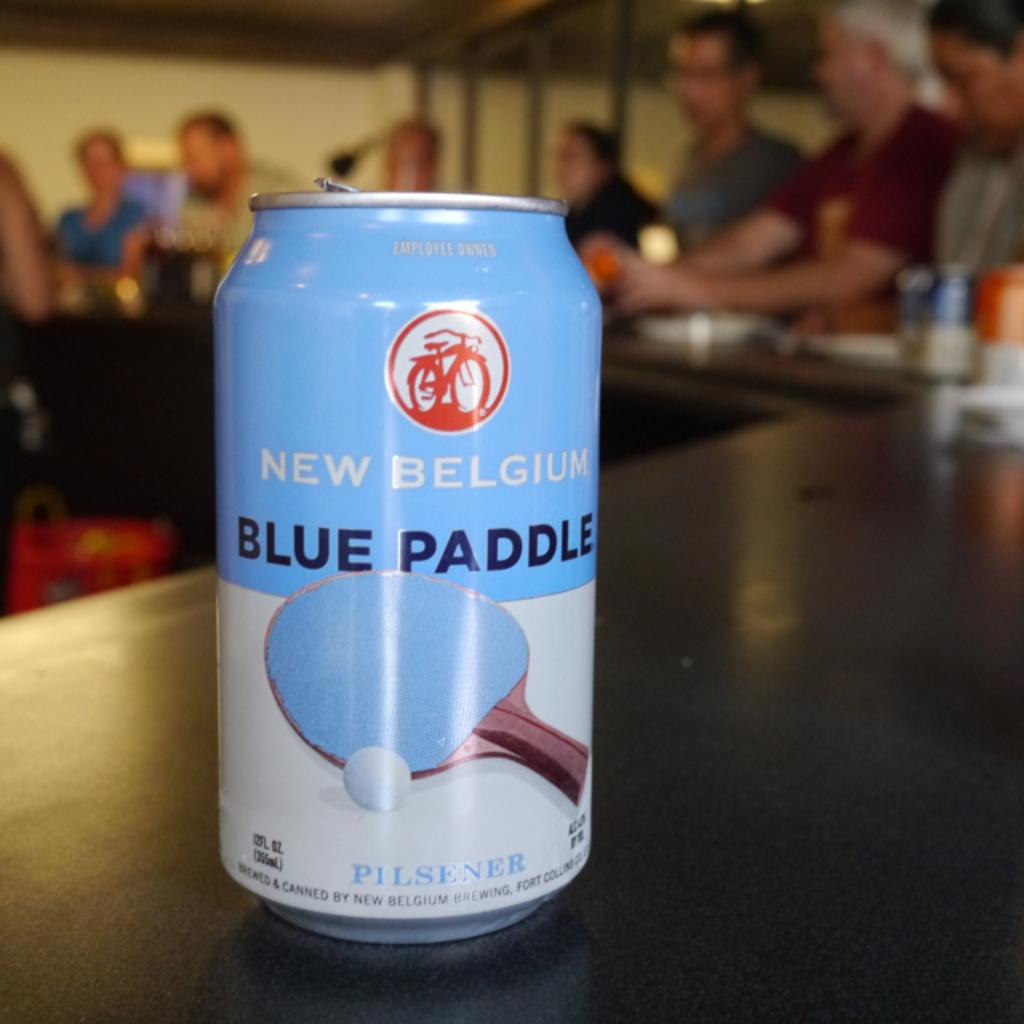What is the main object in the image? There is a tin in the image. What can be seen in the background of the image? In the background, there are persons, a wall, glass windows, and other objects. What is the color of the surface at the bottom of the image? The surface at the bottom of the image is black. What time is depicted on the ear in the image? There is no ear present in the image, and therefore no time can be depicted on it. 